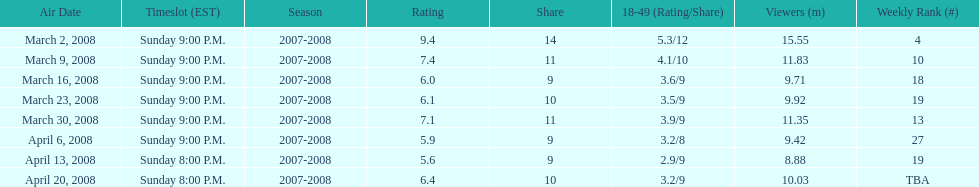The air date with the most viewers March 2, 2008. 